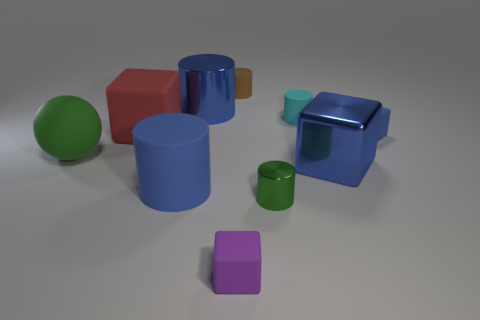Subtract all big red cubes. How many cubes are left? 3 Subtract all yellow cylinders. How many blue blocks are left? 2 Subtract all blue cylinders. How many cylinders are left? 3 Subtract 2 cylinders. How many cylinders are left? 3 Subtract all gray cylinders. Subtract all yellow spheres. How many cylinders are left? 5 Subtract all large matte cylinders. Subtract all large blue shiny things. How many objects are left? 7 Add 4 green matte things. How many green matte things are left? 5 Add 1 small gray shiny balls. How many small gray shiny balls exist? 1 Subtract 0 yellow balls. How many objects are left? 10 Subtract all spheres. How many objects are left? 9 